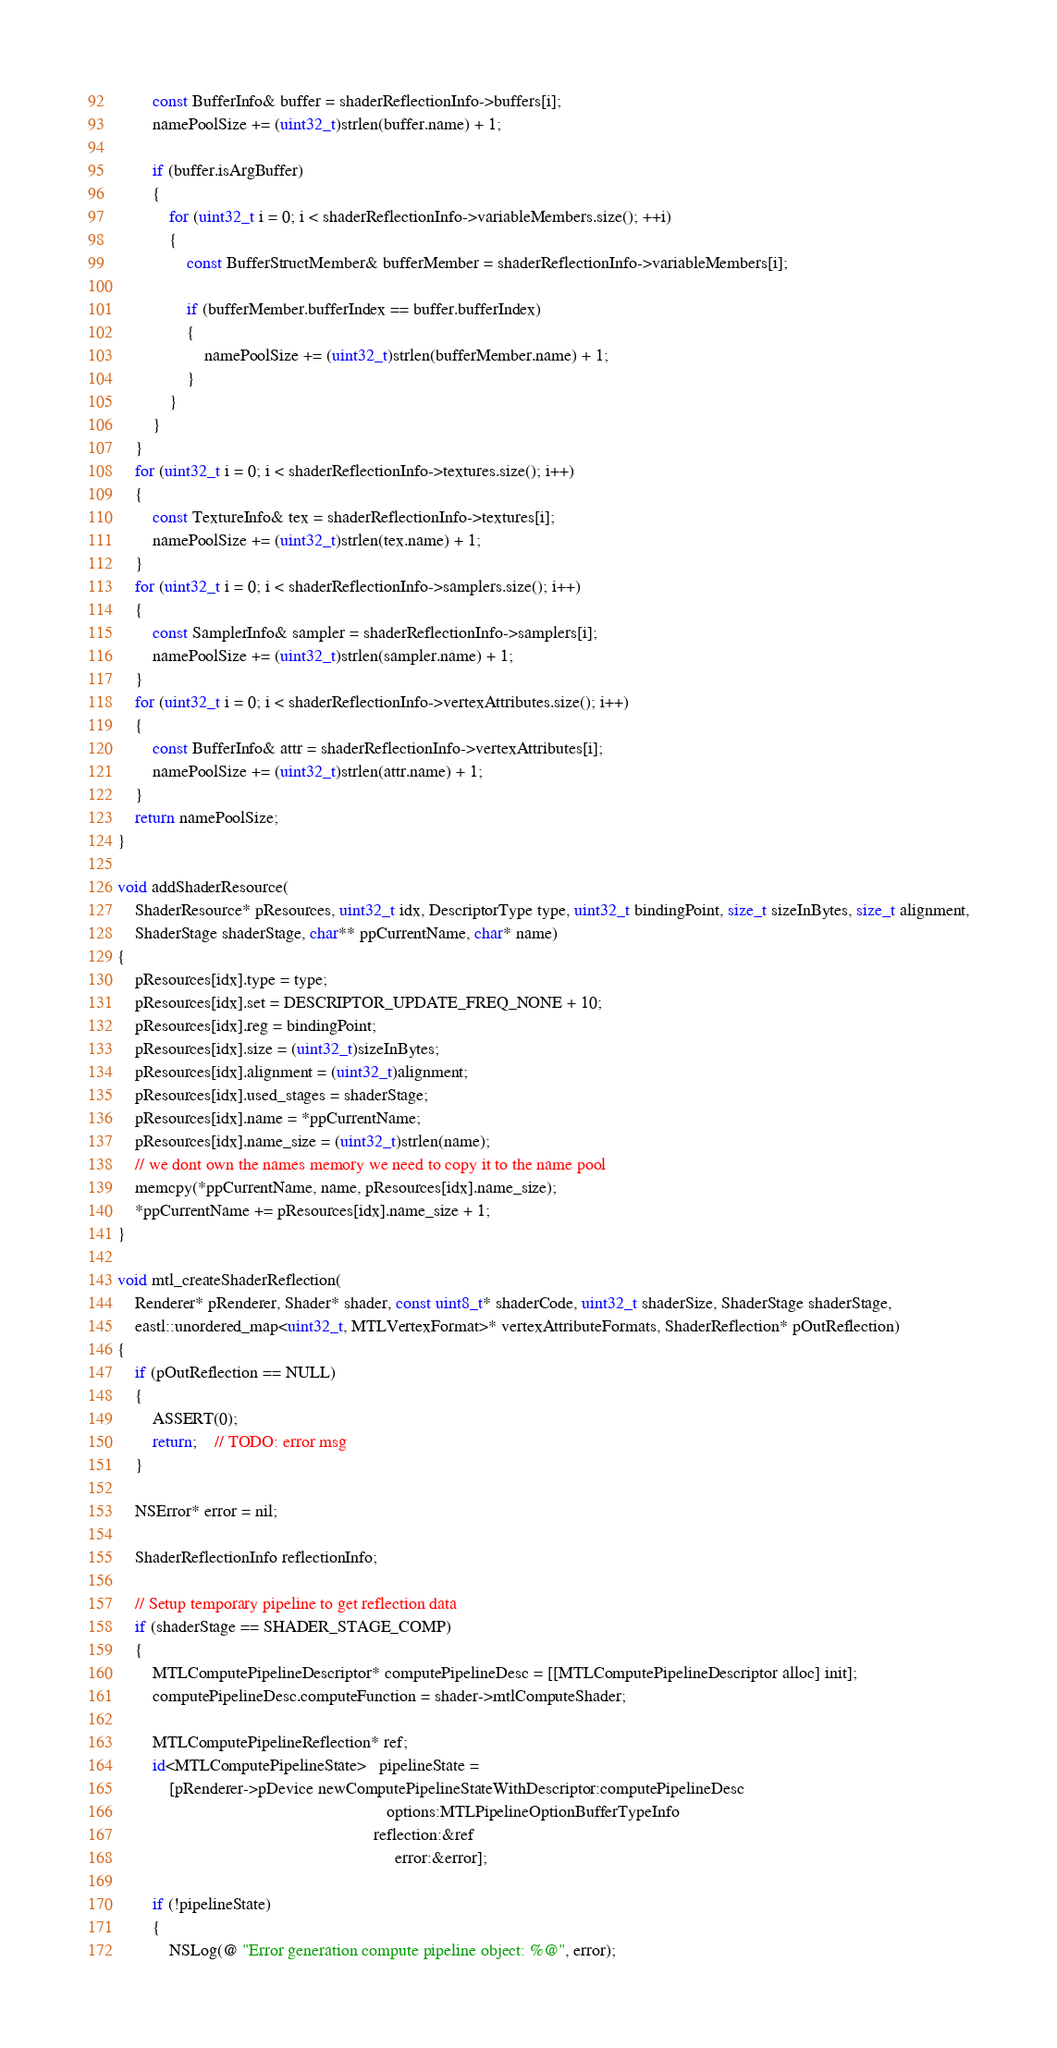Convert code to text. <code><loc_0><loc_0><loc_500><loc_500><_ObjectiveC_>		const BufferInfo& buffer = shaderReflectionInfo->buffers[i];
		namePoolSize += (uint32_t)strlen(buffer.name) + 1;

		if (buffer.isArgBuffer)
		{
			for (uint32_t i = 0; i < shaderReflectionInfo->variableMembers.size(); ++i)
			{
				const BufferStructMember& bufferMember = shaderReflectionInfo->variableMembers[i];

				if (bufferMember.bufferIndex == buffer.bufferIndex)
				{
					namePoolSize += (uint32_t)strlen(bufferMember.name) + 1;
				}
			}
		}
	}
	for (uint32_t i = 0; i < shaderReflectionInfo->textures.size(); i++)
	{
		const TextureInfo& tex = shaderReflectionInfo->textures[i];
		namePoolSize += (uint32_t)strlen(tex.name) + 1;
	}
	for (uint32_t i = 0; i < shaderReflectionInfo->samplers.size(); i++)
	{
		const SamplerInfo& sampler = shaderReflectionInfo->samplers[i];
		namePoolSize += (uint32_t)strlen(sampler.name) + 1;
	}
	for (uint32_t i = 0; i < shaderReflectionInfo->vertexAttributes.size(); i++)
	{
		const BufferInfo& attr = shaderReflectionInfo->vertexAttributes[i];
		namePoolSize += (uint32_t)strlen(attr.name) + 1;
	}
	return namePoolSize;
}

void addShaderResource(
	ShaderResource* pResources, uint32_t idx, DescriptorType type, uint32_t bindingPoint, size_t sizeInBytes, size_t alignment,
	ShaderStage shaderStage, char** ppCurrentName, char* name)
{
	pResources[idx].type = type;
	pResources[idx].set = DESCRIPTOR_UPDATE_FREQ_NONE + 10;
	pResources[idx].reg = bindingPoint;
	pResources[idx].size = (uint32_t)sizeInBytes;
	pResources[idx].alignment = (uint32_t)alignment;
	pResources[idx].used_stages = shaderStage;
	pResources[idx].name = *ppCurrentName;
	pResources[idx].name_size = (uint32_t)strlen(name);
	// we dont own the names memory we need to copy it to the name pool
	memcpy(*ppCurrentName, name, pResources[idx].name_size);
	*ppCurrentName += pResources[idx].name_size + 1;
}

void mtl_createShaderReflection(
	Renderer* pRenderer, Shader* shader, const uint8_t* shaderCode, uint32_t shaderSize, ShaderStage shaderStage,
	eastl::unordered_map<uint32_t, MTLVertexFormat>* vertexAttributeFormats, ShaderReflection* pOutReflection)
{
	if (pOutReflection == NULL)
	{
		ASSERT(0);
		return;    // TODO: error msg
	}

	NSError* error = nil;

	ShaderReflectionInfo reflectionInfo;

	// Setup temporary pipeline to get reflection data
	if (shaderStage == SHADER_STAGE_COMP)
	{
		MTLComputePipelineDescriptor* computePipelineDesc = [[MTLComputePipelineDescriptor alloc] init];
		computePipelineDesc.computeFunction = shader->mtlComputeShader;

		MTLComputePipelineReflection* ref;
		id<MTLComputePipelineState>   pipelineState =
			[pRenderer->pDevice newComputePipelineStateWithDescriptor:computePipelineDesc
															  options:MTLPipelineOptionBufferTypeInfo
														   reflection:&ref
																error:&error];

		if (!pipelineState)
		{
			NSLog(@ "Error generation compute pipeline object: %@", error);</code> 